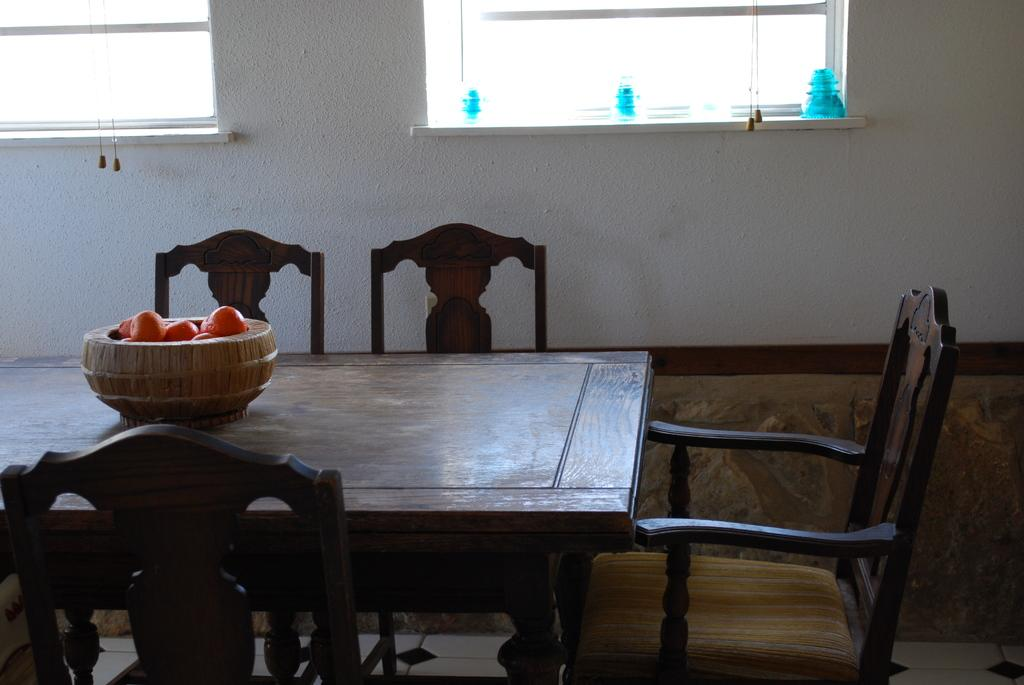What piece of furniture is present in the image? There is a table in the image. What is placed on the table? There is a container on the table. What is inside the container? The container contains various items. How many chairs are around the table? There are 4 chairs around the table. What can be seen in the background of the image? There is a wall and windows in the background of the image. What type of ball is being used to celebrate the birthday in the image? There is no ball or birthday celebration present in the image. How does the moon affect the lighting in the image? The image does not show the moon or any outdoor setting where the moon's light would be visible. 